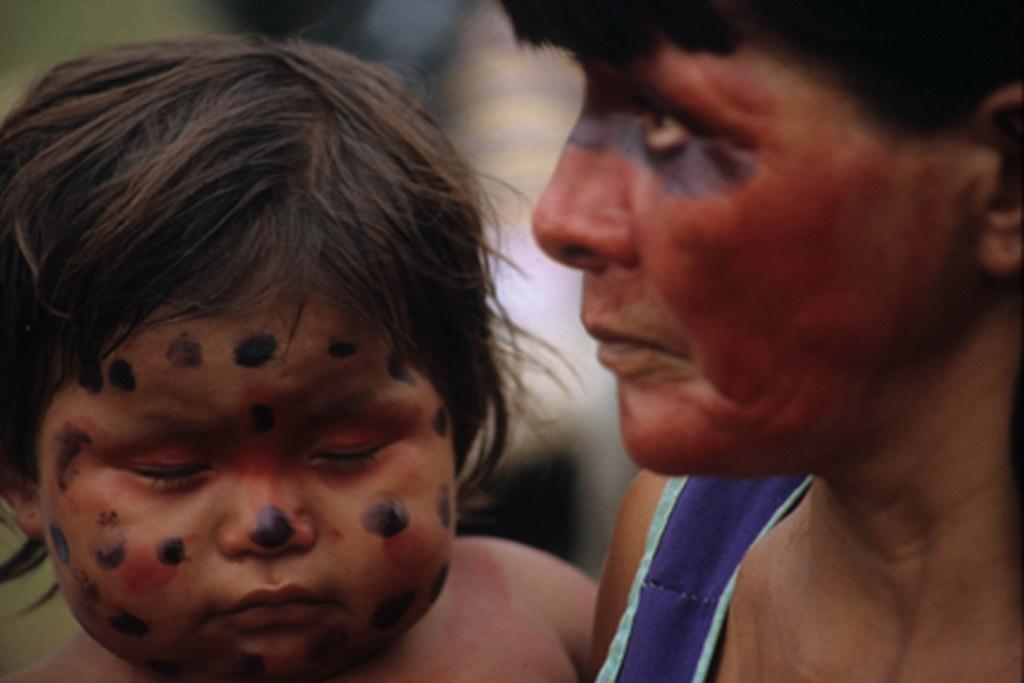Can you describe this image briefly? In this image we can see two persons. A lady is carrying a baby. 